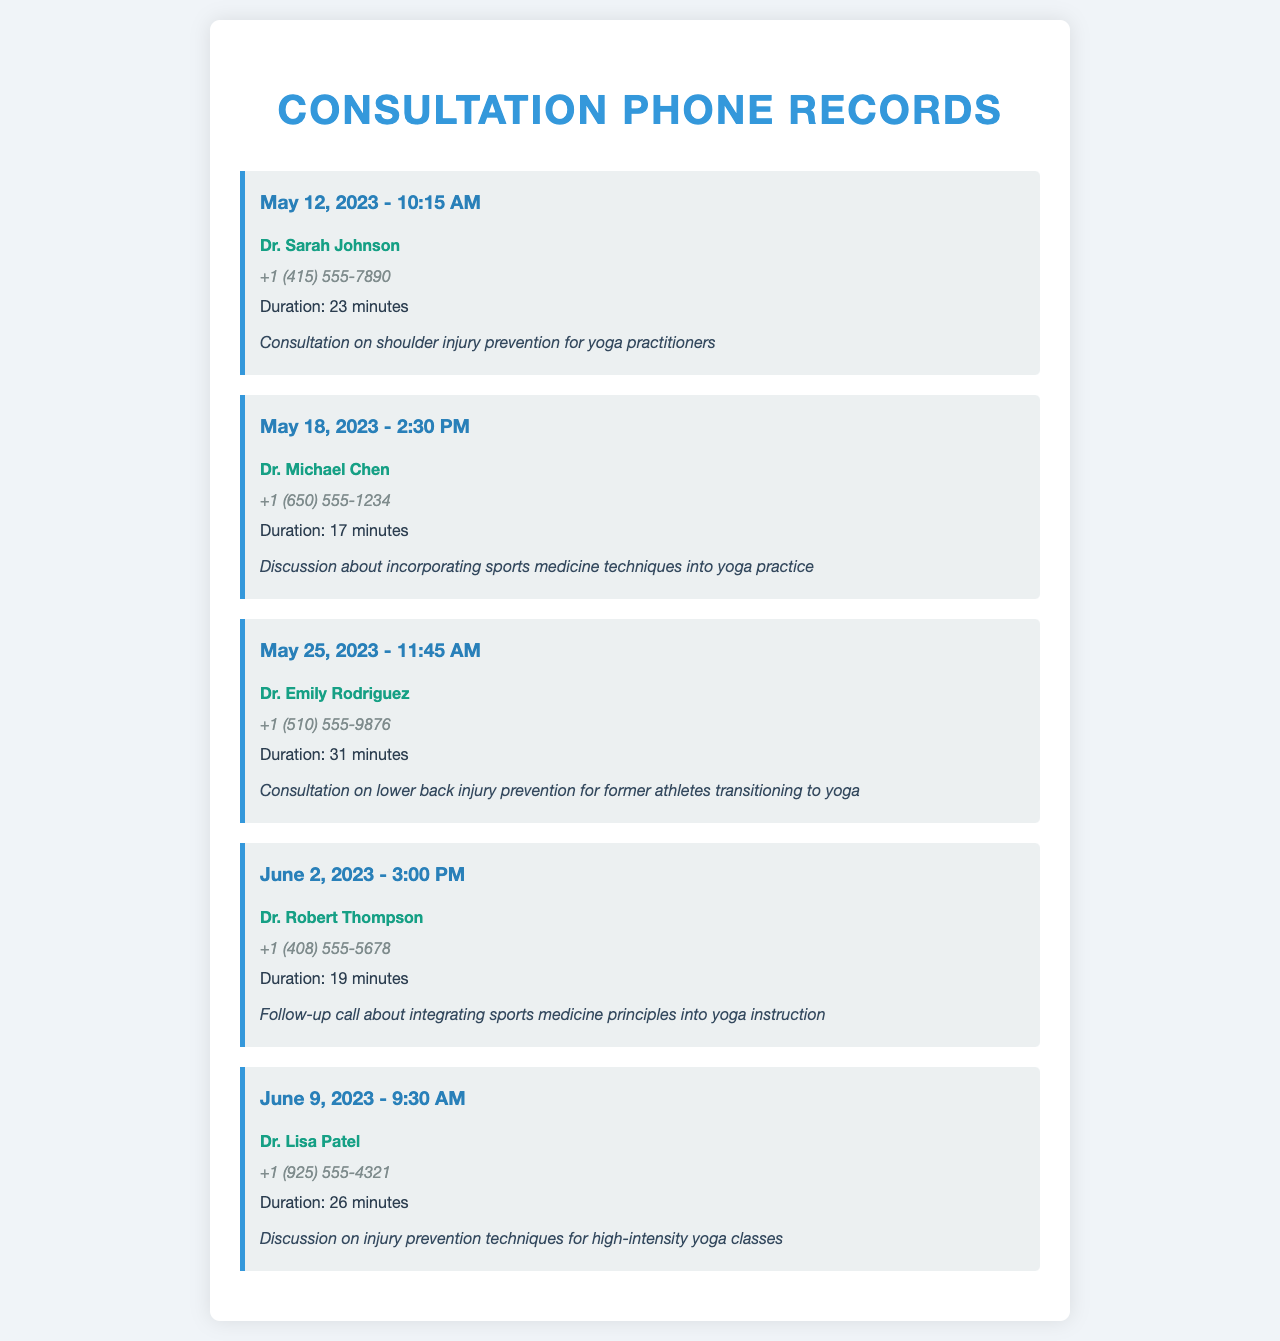what is the date of the first consultation? The first consultation listed in the document is dated May 12, 2023.
Answer: May 12, 2023 who is the contact for the May 18, 2023 consultation? The consultation on May 18, 2023 is with Dr. Michael Chen.
Answer: Dr. Michael Chen how long was the consultation with Dr. Emily Rodriguez? The duration of the consultation with Dr. Emily Rodriguez is 31 minutes.
Answer: 31 minutes what type of injury was discussed during the June 9, 2023 consultation? The consultation on June 9, 2023 discussed injury prevention techniques for high-intensity yoga classes.
Answer: injury prevention techniques for high-intensity yoga classes how many consultations are listed in total? Counting all consultations in the document, there are five in total.
Answer: five what is the primary focus of the consultations listed? The primary focus of all consultations is on injury prevention techniques for yoga practitioners.
Answer: injury prevention techniques for yoga practitioners which doctor discussed lower back injury prevention? The consultation about lower back injury prevention was with Dr. Emily Rodriguez.
Answer: Dr. Emily Rodriguez what was the duration of the follow-up call on June 2, 2023? The follow-up call on June 2, 2023 lasted for 19 minutes.
Answer: 19 minutes 